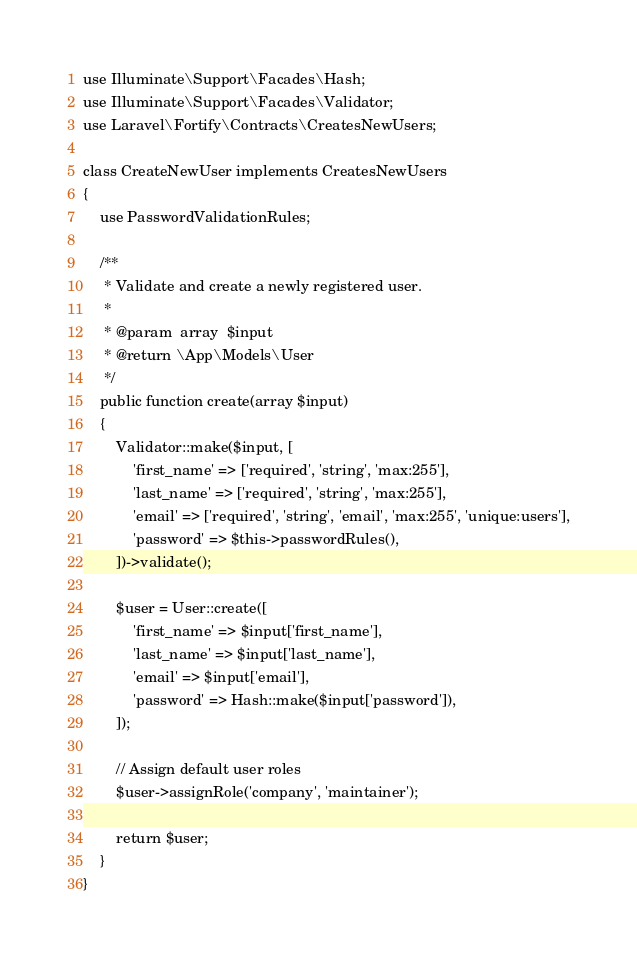Convert code to text. <code><loc_0><loc_0><loc_500><loc_500><_PHP_>use Illuminate\Support\Facades\Hash;
use Illuminate\Support\Facades\Validator;
use Laravel\Fortify\Contracts\CreatesNewUsers;

class CreateNewUser implements CreatesNewUsers
{
    use PasswordValidationRules;

    /**
     * Validate and create a newly registered user.
     *
     * @param  array  $input
     * @return \App\Models\User
     */
    public function create(array $input)
    {
        Validator::make($input, [
            'first_name' => ['required', 'string', 'max:255'],
            'last_name' => ['required', 'string', 'max:255'],
            'email' => ['required', 'string', 'email', 'max:255', 'unique:users'],
            'password' => $this->passwordRules(),
        ])->validate();

        $user = User::create([
            'first_name' => $input['first_name'],
            'last_name' => $input['last_name'],
            'email' => $input['email'],
            'password' => Hash::make($input['password']),
        ]);

        // Assign default user roles
        $user->assignRole('company', 'maintainer');

        return $user;
    }
}
</code> 